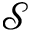<formula> <loc_0><loc_0><loc_500><loc_500>\mathcal { S }</formula> 